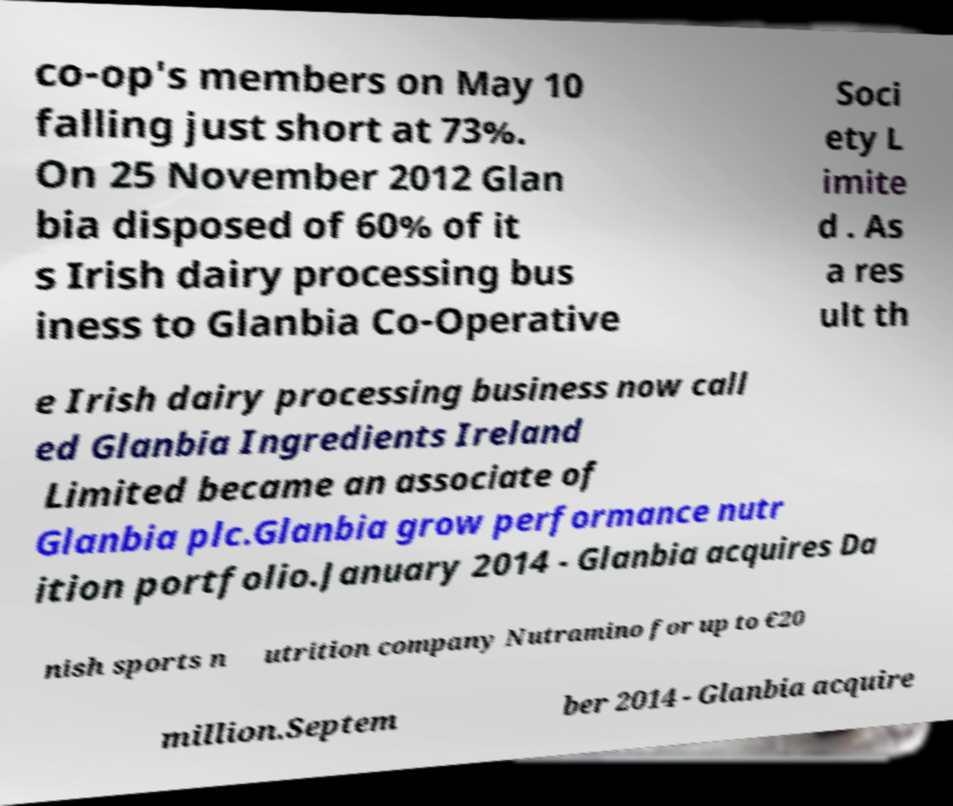Please read and relay the text visible in this image. What does it say? co-op's members on May 10 falling just short at 73%. On 25 November 2012 Glan bia disposed of 60% of it s Irish dairy processing bus iness to Glanbia Co-Operative Soci ety L imite d . As a res ult th e Irish dairy processing business now call ed Glanbia Ingredients Ireland Limited became an associate of Glanbia plc.Glanbia grow performance nutr ition portfolio.January 2014 - Glanbia acquires Da nish sports n utrition company Nutramino for up to €20 million.Septem ber 2014 - Glanbia acquire 